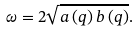<formula> <loc_0><loc_0><loc_500><loc_500>\omega = 2 \sqrt { a \left ( { q } \right ) b \left ( { q } \right ) } .</formula> 